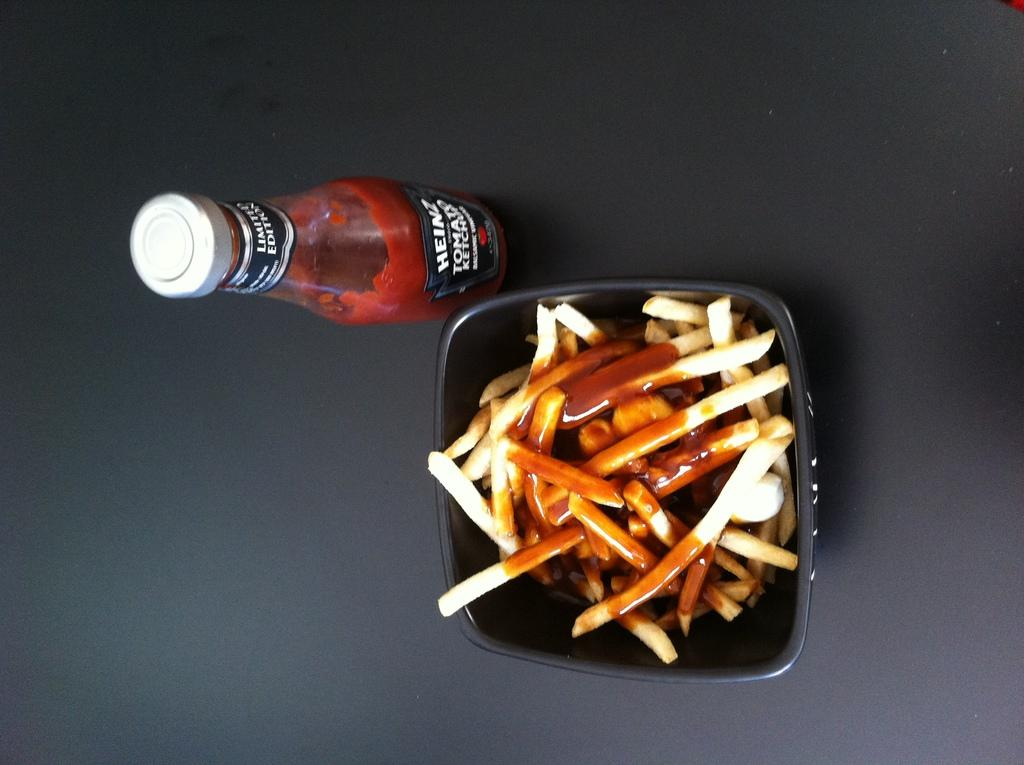What is present in the image that can hold liquids? There is a bottle in the image that can hold liquids. What is present in the image that can hold food? There is a bowl in the image that can hold food. What type of food is in the bowl? There is food in the bowl. Where are the bottle, bowl, and food located in the image? The bottle, bowl, and food are placed on a platform. What company is responsible for the surprise in the image? There is no company or surprise present in the image; it only contains a bottle, a bowl, and food on a platform. 